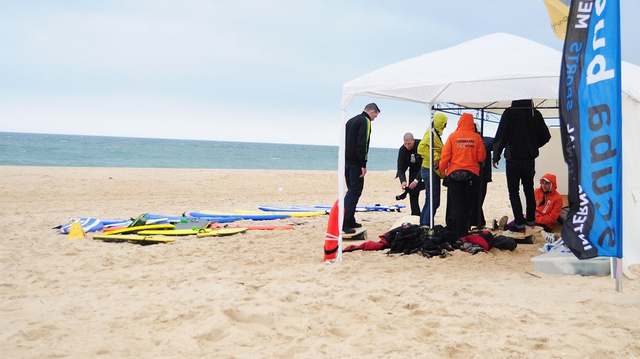Describe the objects in this image and their specific colors. I can see surfboard in lavender, black, brown, and red tones, people in lavender, black, lightgray, and gray tones, people in lavender, black, red, and brown tones, people in lavender, black, lightgray, navy, and gray tones, and people in lavender, black, brown, gray, and white tones in this image. 